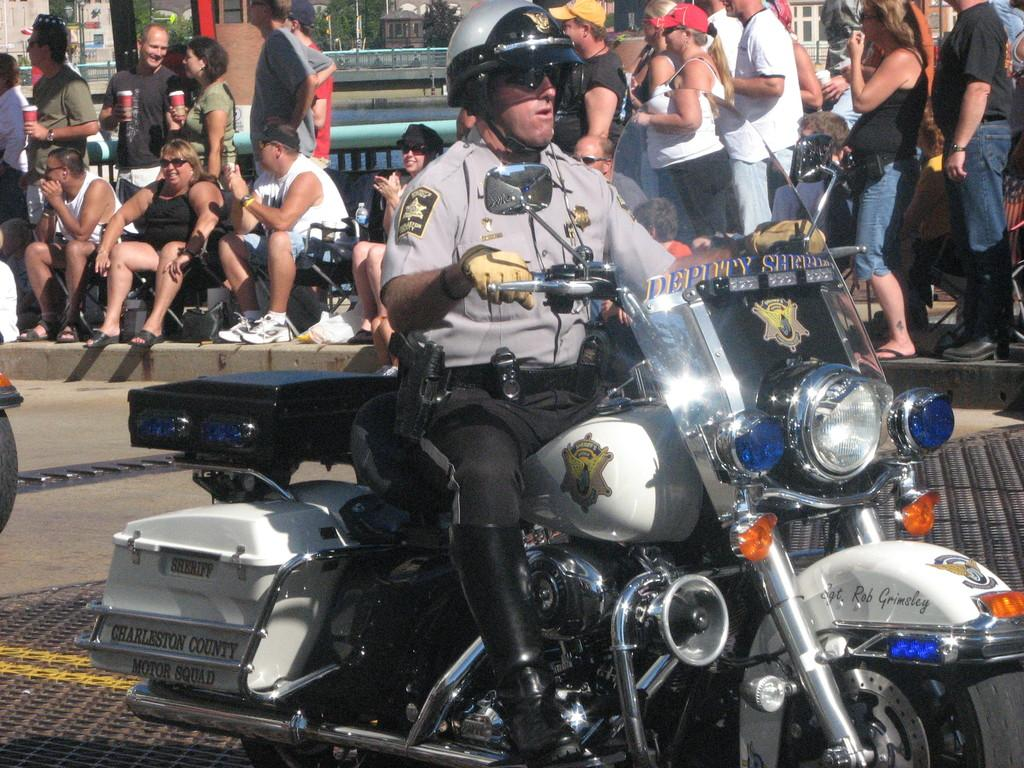What are the people in the image doing? Some people are sitting on chairs, while others are standing in the image. Can you describe the man in the front of the image? The man in the front of the image is sitting on a motorcycle. How many spiders can be seen crawling on the people in the image? There are no spiders present in the image; it only features people sitting, standing, and a man on a motorcycle. 